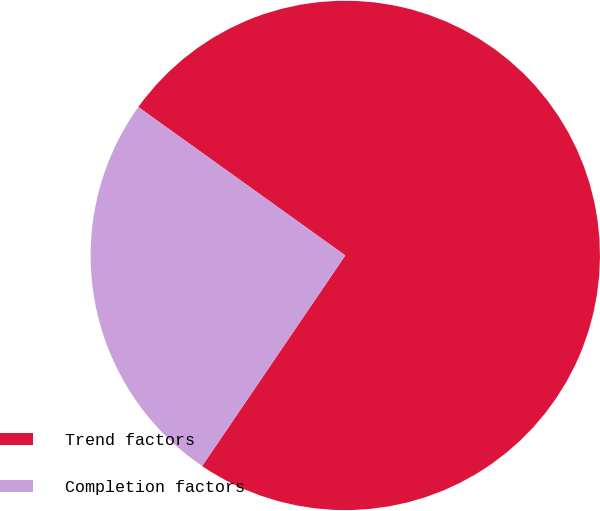Convert chart. <chart><loc_0><loc_0><loc_500><loc_500><pie_chart><fcel>Trend factors<fcel>Completion factors<nl><fcel>74.6%<fcel>25.4%<nl></chart> 